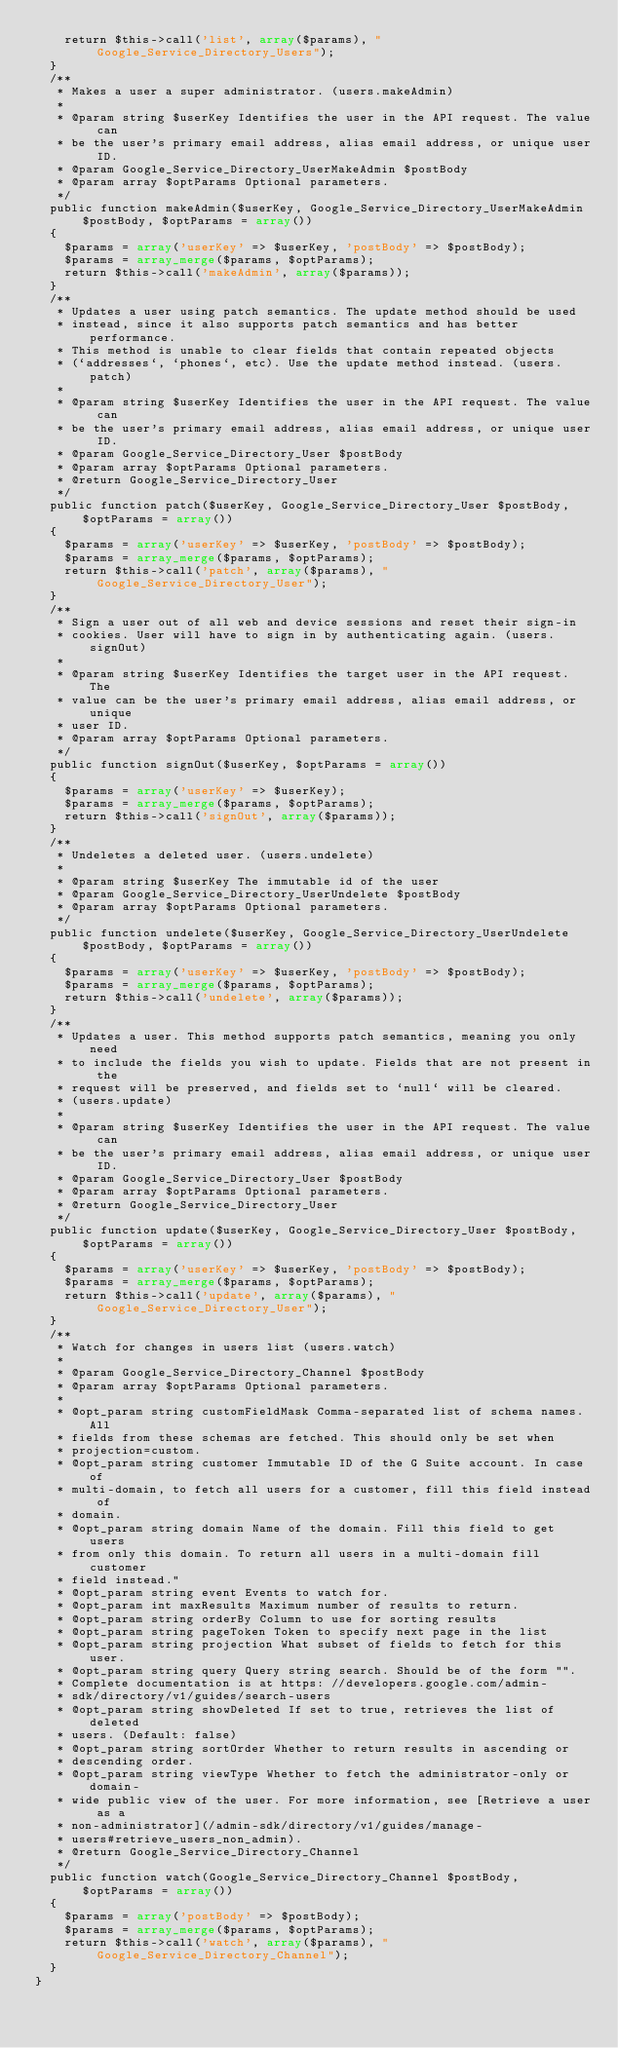Convert code to text. <code><loc_0><loc_0><loc_500><loc_500><_PHP_>    return $this->call('list', array($params), "Google_Service_Directory_Users");
  }
  /**
   * Makes a user a super administrator. (users.makeAdmin)
   *
   * @param string $userKey Identifies the user in the API request. The value can
   * be the user's primary email address, alias email address, or unique user ID.
   * @param Google_Service_Directory_UserMakeAdmin $postBody
   * @param array $optParams Optional parameters.
   */
  public function makeAdmin($userKey, Google_Service_Directory_UserMakeAdmin $postBody, $optParams = array())
  {
    $params = array('userKey' => $userKey, 'postBody' => $postBody);
    $params = array_merge($params, $optParams);
    return $this->call('makeAdmin', array($params));
  }
  /**
   * Updates a user using patch semantics. The update method should be used
   * instead, since it also supports patch semantics and has better performance.
   * This method is unable to clear fields that contain repeated objects
   * (`addresses`, `phones`, etc). Use the update method instead. (users.patch)
   *
   * @param string $userKey Identifies the user in the API request. The value can
   * be the user's primary email address, alias email address, or unique user ID.
   * @param Google_Service_Directory_User $postBody
   * @param array $optParams Optional parameters.
   * @return Google_Service_Directory_User
   */
  public function patch($userKey, Google_Service_Directory_User $postBody, $optParams = array())
  {
    $params = array('userKey' => $userKey, 'postBody' => $postBody);
    $params = array_merge($params, $optParams);
    return $this->call('patch', array($params), "Google_Service_Directory_User");
  }
  /**
   * Sign a user out of all web and device sessions and reset their sign-in
   * cookies. User will have to sign in by authenticating again. (users.signOut)
   *
   * @param string $userKey Identifies the target user in the API request. The
   * value can be the user's primary email address, alias email address, or unique
   * user ID.
   * @param array $optParams Optional parameters.
   */
  public function signOut($userKey, $optParams = array())
  {
    $params = array('userKey' => $userKey);
    $params = array_merge($params, $optParams);
    return $this->call('signOut', array($params));
  }
  /**
   * Undeletes a deleted user. (users.undelete)
   *
   * @param string $userKey The immutable id of the user
   * @param Google_Service_Directory_UserUndelete $postBody
   * @param array $optParams Optional parameters.
   */
  public function undelete($userKey, Google_Service_Directory_UserUndelete $postBody, $optParams = array())
  {
    $params = array('userKey' => $userKey, 'postBody' => $postBody);
    $params = array_merge($params, $optParams);
    return $this->call('undelete', array($params));
  }
  /**
   * Updates a user. This method supports patch semantics, meaning you only need
   * to include the fields you wish to update. Fields that are not present in the
   * request will be preserved, and fields set to `null` will be cleared.
   * (users.update)
   *
   * @param string $userKey Identifies the user in the API request. The value can
   * be the user's primary email address, alias email address, or unique user ID.
   * @param Google_Service_Directory_User $postBody
   * @param array $optParams Optional parameters.
   * @return Google_Service_Directory_User
   */
  public function update($userKey, Google_Service_Directory_User $postBody, $optParams = array())
  {
    $params = array('userKey' => $userKey, 'postBody' => $postBody);
    $params = array_merge($params, $optParams);
    return $this->call('update', array($params), "Google_Service_Directory_User");
  }
  /**
   * Watch for changes in users list (users.watch)
   *
   * @param Google_Service_Directory_Channel $postBody
   * @param array $optParams Optional parameters.
   *
   * @opt_param string customFieldMask Comma-separated list of schema names. All
   * fields from these schemas are fetched. This should only be set when
   * projection=custom.
   * @opt_param string customer Immutable ID of the G Suite account. In case of
   * multi-domain, to fetch all users for a customer, fill this field instead of
   * domain.
   * @opt_param string domain Name of the domain. Fill this field to get users
   * from only this domain. To return all users in a multi-domain fill customer
   * field instead."
   * @opt_param string event Events to watch for.
   * @opt_param int maxResults Maximum number of results to return.
   * @opt_param string orderBy Column to use for sorting results
   * @opt_param string pageToken Token to specify next page in the list
   * @opt_param string projection What subset of fields to fetch for this user.
   * @opt_param string query Query string search. Should be of the form "".
   * Complete documentation is at https: //developers.google.com/admin-
   * sdk/directory/v1/guides/search-users
   * @opt_param string showDeleted If set to true, retrieves the list of deleted
   * users. (Default: false)
   * @opt_param string sortOrder Whether to return results in ascending or
   * descending order.
   * @opt_param string viewType Whether to fetch the administrator-only or domain-
   * wide public view of the user. For more information, see [Retrieve a user as a
   * non-administrator](/admin-sdk/directory/v1/guides/manage-
   * users#retrieve_users_non_admin).
   * @return Google_Service_Directory_Channel
   */
  public function watch(Google_Service_Directory_Channel $postBody, $optParams = array())
  {
    $params = array('postBody' => $postBody);
    $params = array_merge($params, $optParams);
    return $this->call('watch', array($params), "Google_Service_Directory_Channel");
  }
}
</code> 